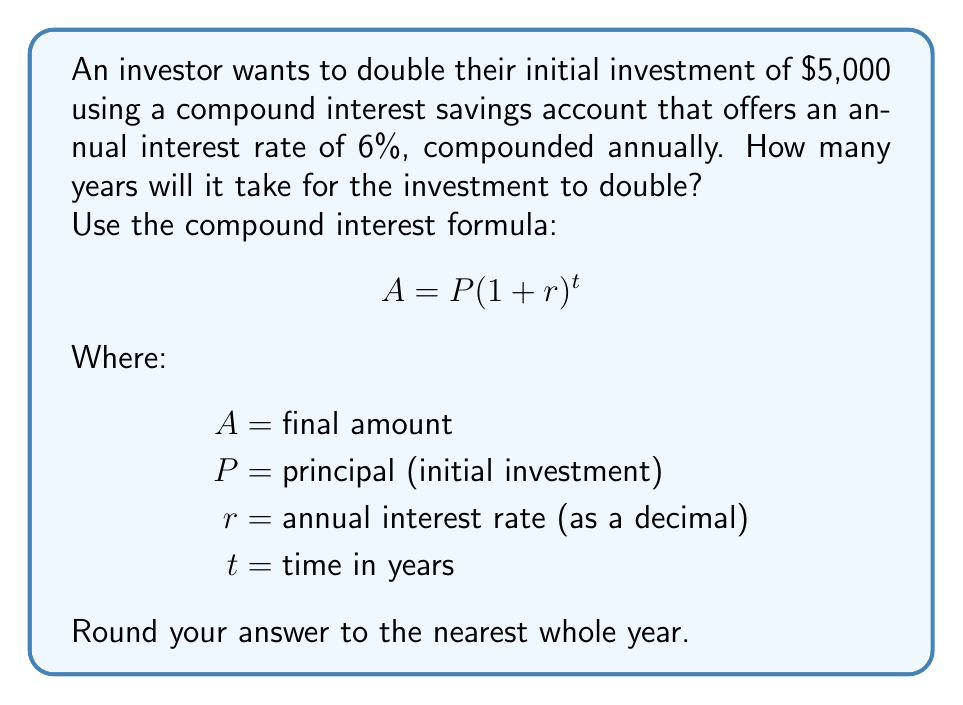Give your solution to this math problem. To solve this problem, we'll use the compound interest formula and the concept of doubling time:

1. We know that we want the final amount ($A$) to be double the initial investment ($P$):
   $A = 2P$

2. Substituting this into the compound interest formula:
   $$2P = P(1 + r)^t$$

3. Simplify by dividing both sides by $P$:
   $$2 = (1 + r)^t$$

4. Take the natural logarithm of both sides:
   $$\ln(2) = t \cdot \ln(1 + r)$$

5. Solve for $t$:
   $$t = \frac{\ln(2)}{\ln(1 + r)}$$

6. Now, let's plug in our values:
   $r = 0.06$ (6% as a decimal)

   $$t = \frac{\ln(2)}{\ln(1 + 0.06)}$$

7. Use a calculator or Python to compute this:
   $$t = \frac{0.6931471805599453}{0.05826891243725417} \approx 11.89$$

8. Rounding to the nearest whole year:
   $t \approx 12$ years

Therefore, it will take approximately 12 years for the investment to double.
Answer: 12 years 